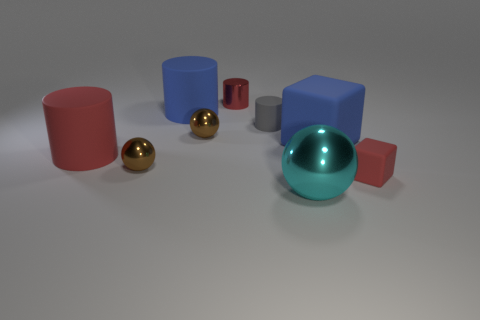Are the red cylinder that is behind the large red rubber thing and the blue thing that is on the left side of the large cyan shiny object made of the same material?
Your response must be concise. No. There is a shiny ball that is on the right side of the big blue cylinder and behind the large metal thing; what size is it?
Offer a terse response. Small. There is a sphere that is the same size as the blue rubber cube; what is its material?
Provide a succinct answer. Metal. There is a small brown metallic ball behind the tiny brown metallic ball that is in front of the big cube; how many brown things are behind it?
Give a very brief answer. 0. There is a tiny cylinder behind the tiny gray rubber cylinder; does it have the same color as the tiny shiny ball behind the large rubber block?
Provide a succinct answer. No. There is a metallic object that is on the right side of the blue rubber cylinder and left of the small red shiny cylinder; what is its color?
Offer a terse response. Brown. How many blue blocks have the same size as the metallic cylinder?
Your response must be concise. 0. The big blue object on the right side of the tiny red object on the left side of the small red block is what shape?
Your answer should be very brief. Cube. The red matte thing on the left side of the red cylinder behind the red matte object left of the tiny cube is what shape?
Your response must be concise. Cylinder. How many other cyan objects are the same shape as the large metallic object?
Give a very brief answer. 0. 